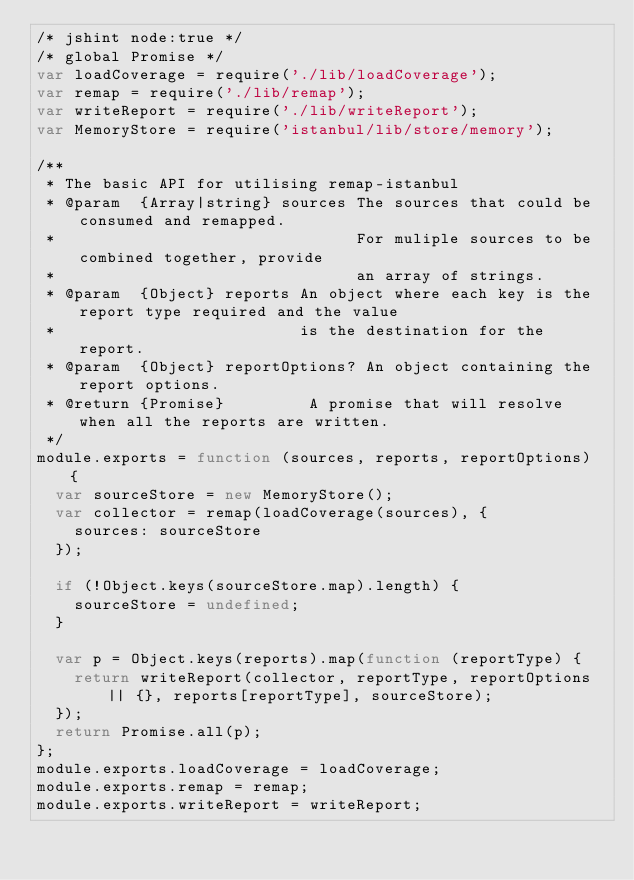Convert code to text. <code><loc_0><loc_0><loc_500><loc_500><_JavaScript_>/* jshint node:true */
/* global Promise */
var loadCoverage = require('./lib/loadCoverage');
var remap = require('./lib/remap');
var writeReport = require('./lib/writeReport');
var MemoryStore = require('istanbul/lib/store/memory');

/**
 * The basic API for utilising remap-istanbul
 * @param  {Array|string} sources The sources that could be consumed and remapped.
 *                                For muliple sources to be combined together, provide
 *                                an array of strings.
 * @param  {Object} reports An object where each key is the report type required and the value
 *                          is the destination for the report.
 * @param  {Object} reportOptions? An object containing the report options.
 * @return {Promise}         A promise that will resolve when all the reports are written.
 */
module.exports = function (sources, reports, reportOptions) {
	var sourceStore = new MemoryStore();
	var collector = remap(loadCoverage(sources), {
		sources: sourceStore
	});

	if (!Object.keys(sourceStore.map).length) {
		sourceStore = undefined;
	}

	var p = Object.keys(reports).map(function (reportType) {
		return writeReport(collector, reportType, reportOptions || {}, reports[reportType], sourceStore);
	});
	return Promise.all(p);
};
module.exports.loadCoverage = loadCoverage;
module.exports.remap = remap;
module.exports.writeReport = writeReport;
</code> 